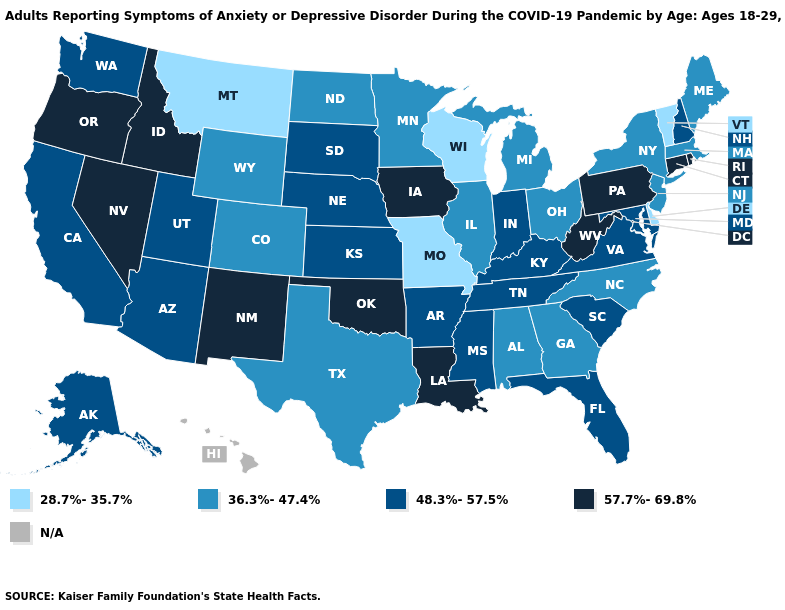Name the states that have a value in the range 36.3%-47.4%?
Write a very short answer. Alabama, Colorado, Georgia, Illinois, Maine, Massachusetts, Michigan, Minnesota, New Jersey, New York, North Carolina, North Dakota, Ohio, Texas, Wyoming. Among the states that border Nevada , does Arizona have the highest value?
Give a very brief answer. No. Does the map have missing data?
Short answer required. Yes. What is the value of Montana?
Give a very brief answer. 28.7%-35.7%. Is the legend a continuous bar?
Answer briefly. No. What is the value of Iowa?
Keep it brief. 57.7%-69.8%. Name the states that have a value in the range 28.7%-35.7%?
Give a very brief answer. Delaware, Missouri, Montana, Vermont, Wisconsin. What is the value of Montana?
Be succinct. 28.7%-35.7%. Which states have the lowest value in the Northeast?
Give a very brief answer. Vermont. What is the lowest value in the USA?
Concise answer only. 28.7%-35.7%. Among the states that border South Dakota , which have the highest value?
Give a very brief answer. Iowa. Does Utah have the highest value in the West?
Keep it brief. No. Which states have the highest value in the USA?
Write a very short answer. Connecticut, Idaho, Iowa, Louisiana, Nevada, New Mexico, Oklahoma, Oregon, Pennsylvania, Rhode Island, West Virginia. Which states hav the highest value in the MidWest?
Quick response, please. Iowa. 